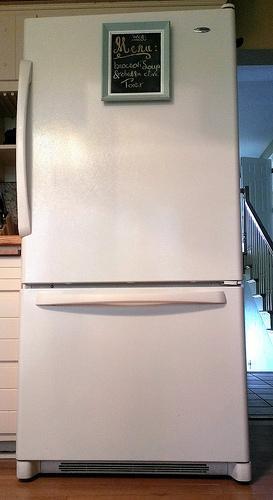How many refrigerators are there?
Give a very brief answer. 1. How many handles are there?
Give a very brief answer. 2. 